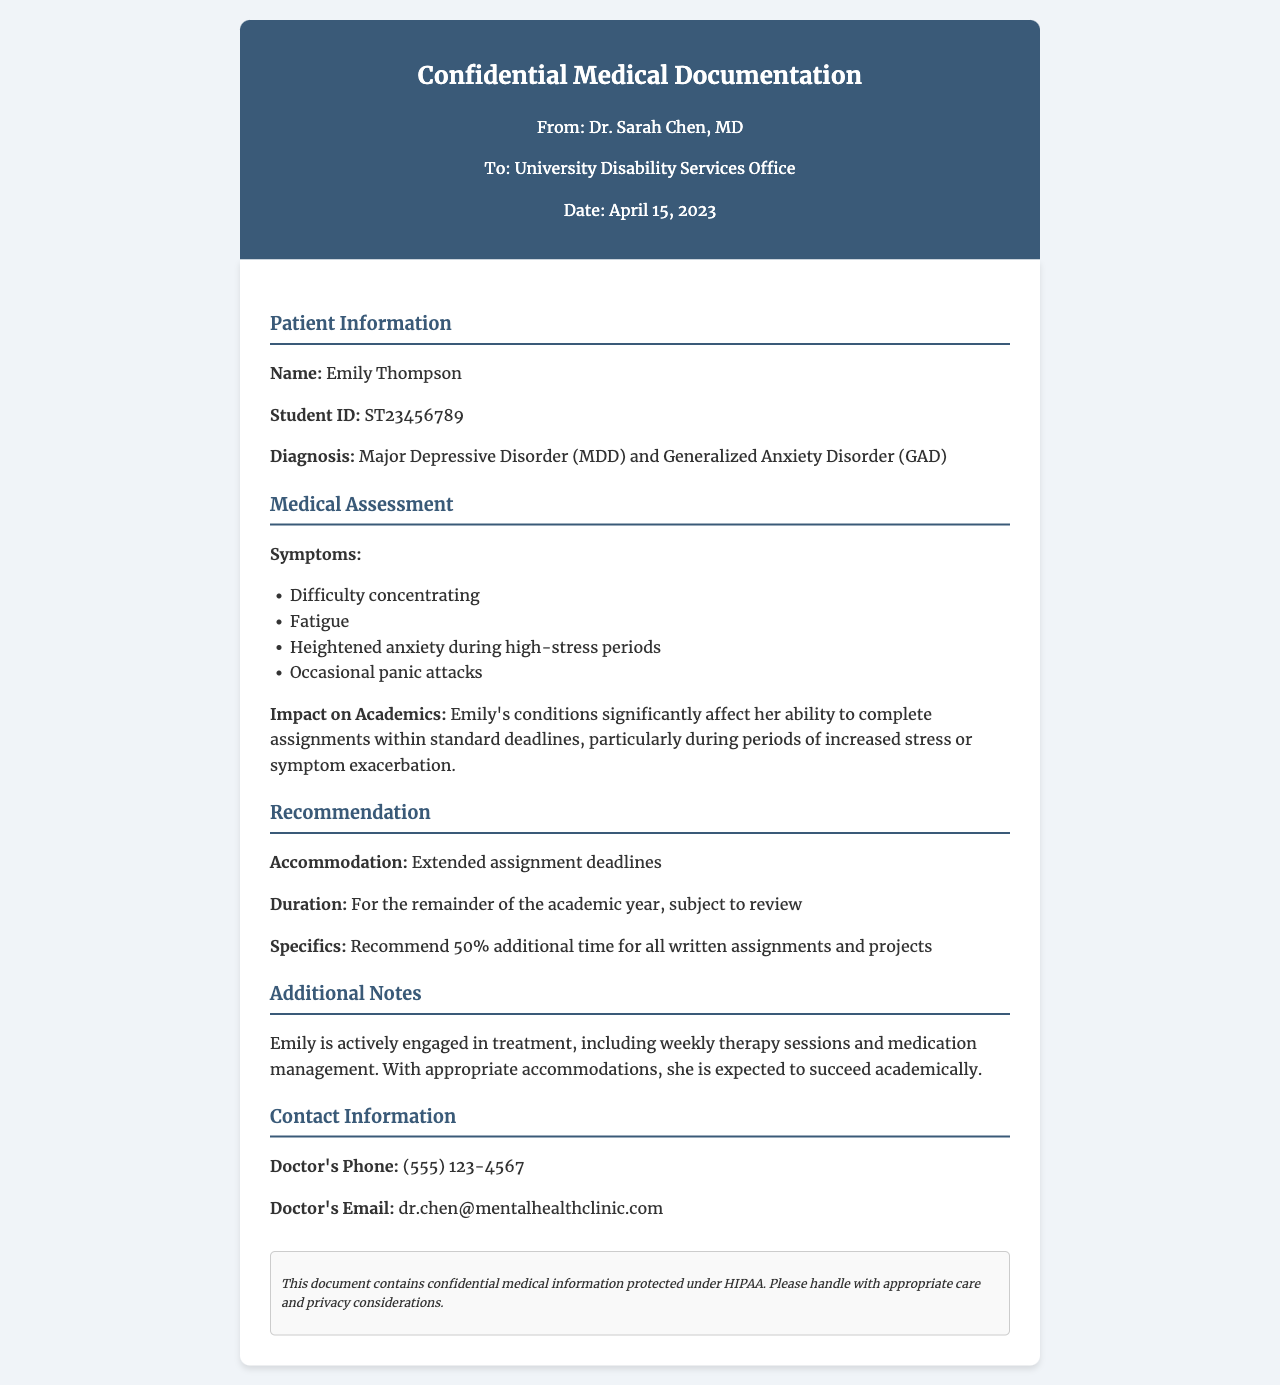What is the patient's name? The document specifies the name of the patient at the beginning under the patient information section.
Answer: Emily Thompson What is the patient's student ID? The student ID is listed directly following the patient's name in the document.
Answer: ST23456789 What are the diagnosed conditions? The document lists the patient's diagnosis in the patient information section.
Answer: Major Depressive Disorder (MDD) and Generalized Anxiety Disorder (GAD) What accommodations are recommended? The document explicitly states the recommended accommodation in the recommendation section.
Answer: Extended assignment deadlines What is the duration of the recommended accommodations? The duration of the accommodations is mentioned in the recommendation section.
Answer: For the remainder of the academic year, subject to review What specific extension is recommended for assignments? The document provides specific details regarding the recommendation for assignment time extensions.
Answer: 50% additional time How does the patient's condition impact academics? The document discusses the impact of the patient's conditions on academic performance in the medical assessment section.
Answer: Significantly affect her ability to complete assignments within standard deadlines What is the doctor's phone number? The contact information section provides the doctor's phone number for further communication.
Answer: (555) 123-4567 What type of document is this? This document is explicitly labeled at the top in the header section.
Answer: Confidential Medical Documentation What is the confidentiality notice about? The confidentiality notice at the bottom details the handling of the document based on legal protections.
Answer: Protected under HIPAA 